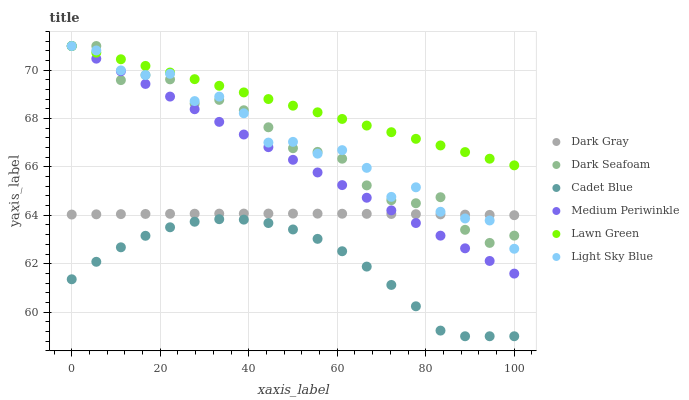Does Cadet Blue have the minimum area under the curve?
Answer yes or no. Yes. Does Lawn Green have the maximum area under the curve?
Answer yes or no. Yes. Does Medium Periwinkle have the minimum area under the curve?
Answer yes or no. No. Does Medium Periwinkle have the maximum area under the curve?
Answer yes or no. No. Is Lawn Green the smoothest?
Answer yes or no. Yes. Is Light Sky Blue the roughest?
Answer yes or no. Yes. Is Cadet Blue the smoothest?
Answer yes or no. No. Is Cadet Blue the roughest?
Answer yes or no. No. Does Cadet Blue have the lowest value?
Answer yes or no. Yes. Does Medium Periwinkle have the lowest value?
Answer yes or no. No. Does Light Sky Blue have the highest value?
Answer yes or no. Yes. Does Cadet Blue have the highest value?
Answer yes or no. No. Is Cadet Blue less than Dark Seafoam?
Answer yes or no. Yes. Is Medium Periwinkle greater than Cadet Blue?
Answer yes or no. Yes. Does Medium Periwinkle intersect Dark Seafoam?
Answer yes or no. Yes. Is Medium Periwinkle less than Dark Seafoam?
Answer yes or no. No. Is Medium Periwinkle greater than Dark Seafoam?
Answer yes or no. No. Does Cadet Blue intersect Dark Seafoam?
Answer yes or no. No. 